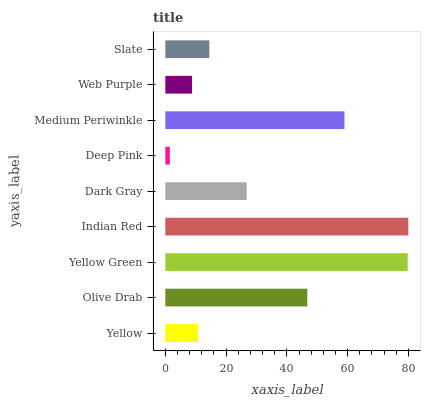Is Deep Pink the minimum?
Answer yes or no. Yes. Is Indian Red the maximum?
Answer yes or no. Yes. Is Olive Drab the minimum?
Answer yes or no. No. Is Olive Drab the maximum?
Answer yes or no. No. Is Olive Drab greater than Yellow?
Answer yes or no. Yes. Is Yellow less than Olive Drab?
Answer yes or no. Yes. Is Yellow greater than Olive Drab?
Answer yes or no. No. Is Olive Drab less than Yellow?
Answer yes or no. No. Is Dark Gray the high median?
Answer yes or no. Yes. Is Dark Gray the low median?
Answer yes or no. Yes. Is Indian Red the high median?
Answer yes or no. No. Is Olive Drab the low median?
Answer yes or no. No. 